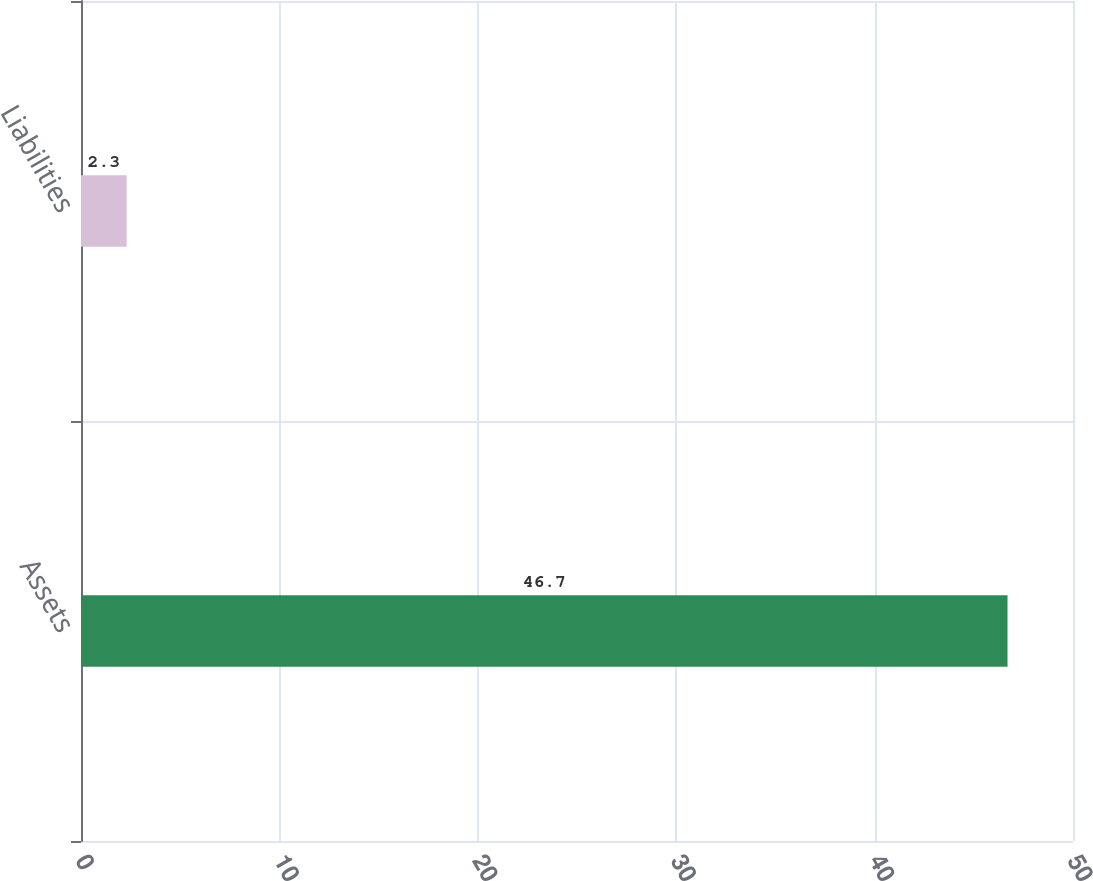Convert chart to OTSL. <chart><loc_0><loc_0><loc_500><loc_500><bar_chart><fcel>Assets<fcel>Liabilities<nl><fcel>46.7<fcel>2.3<nl></chart> 